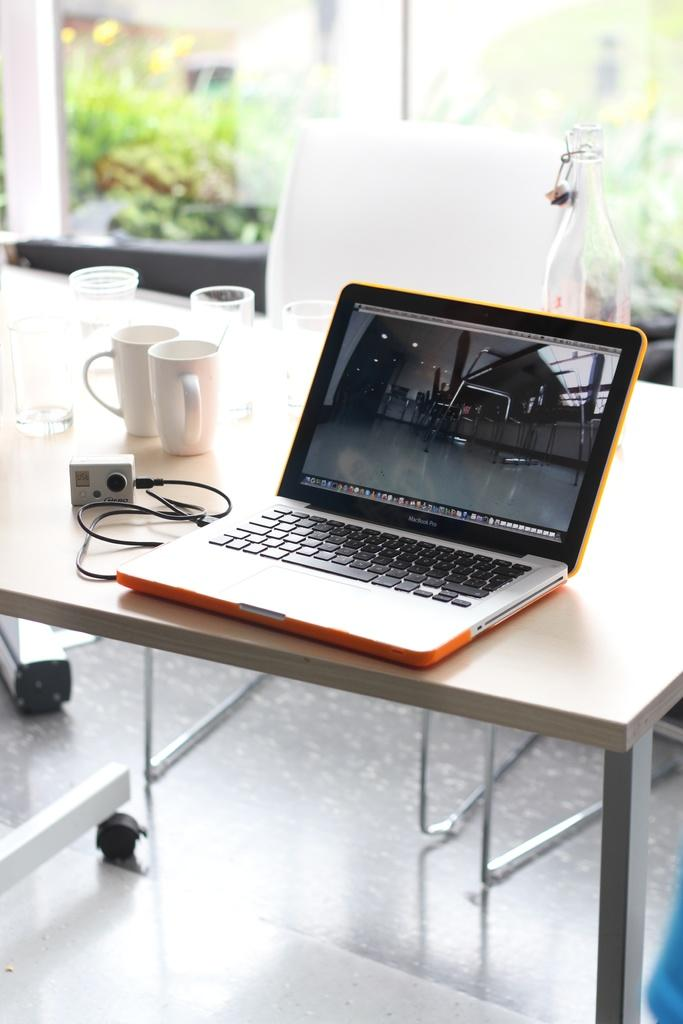What electronic device is visible in the image? There is in the image. A: There is a laptop in the image. What object is used for connecting devices in the image? There is a connector in the image. What type of containers are present in the image? There is a glass and a cup in the image. Where are all these objects located? All these objects are on a table in the image. What can be seen through the window in the image? Trees are visible through the window glass in the image. What type of argument is taking place in the image? There is no argument present in the image; it only shows a laptop, connector, glass, cup, table, window glass, and trees visible through the window. 